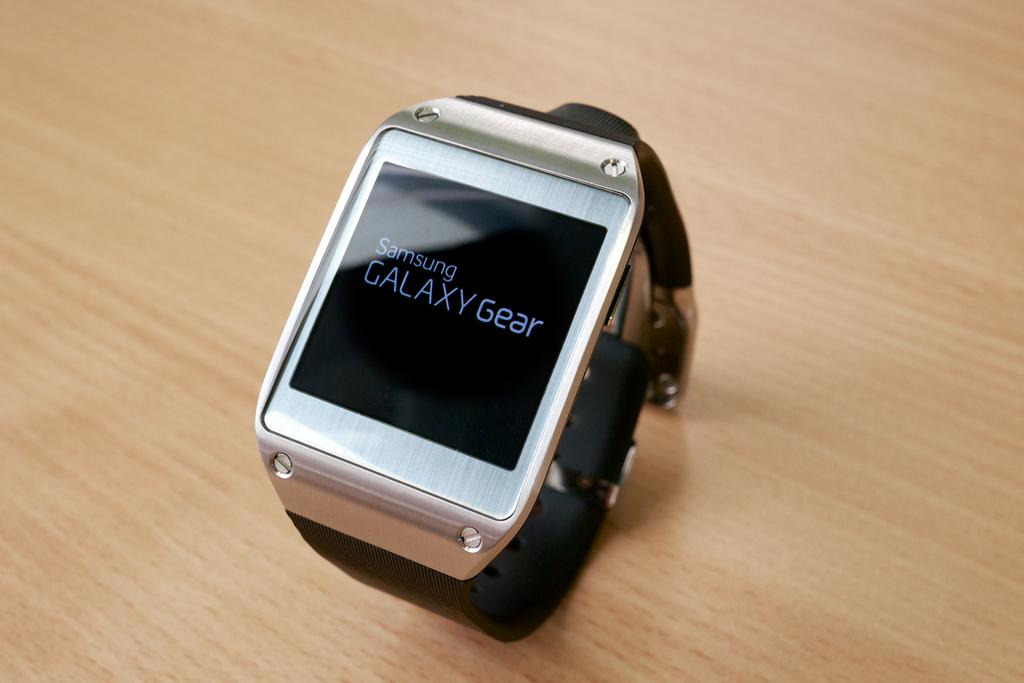<image>
Create a compact narrative representing the image presented. A Samsung galaxy gear smartwatch on a wooden table. 